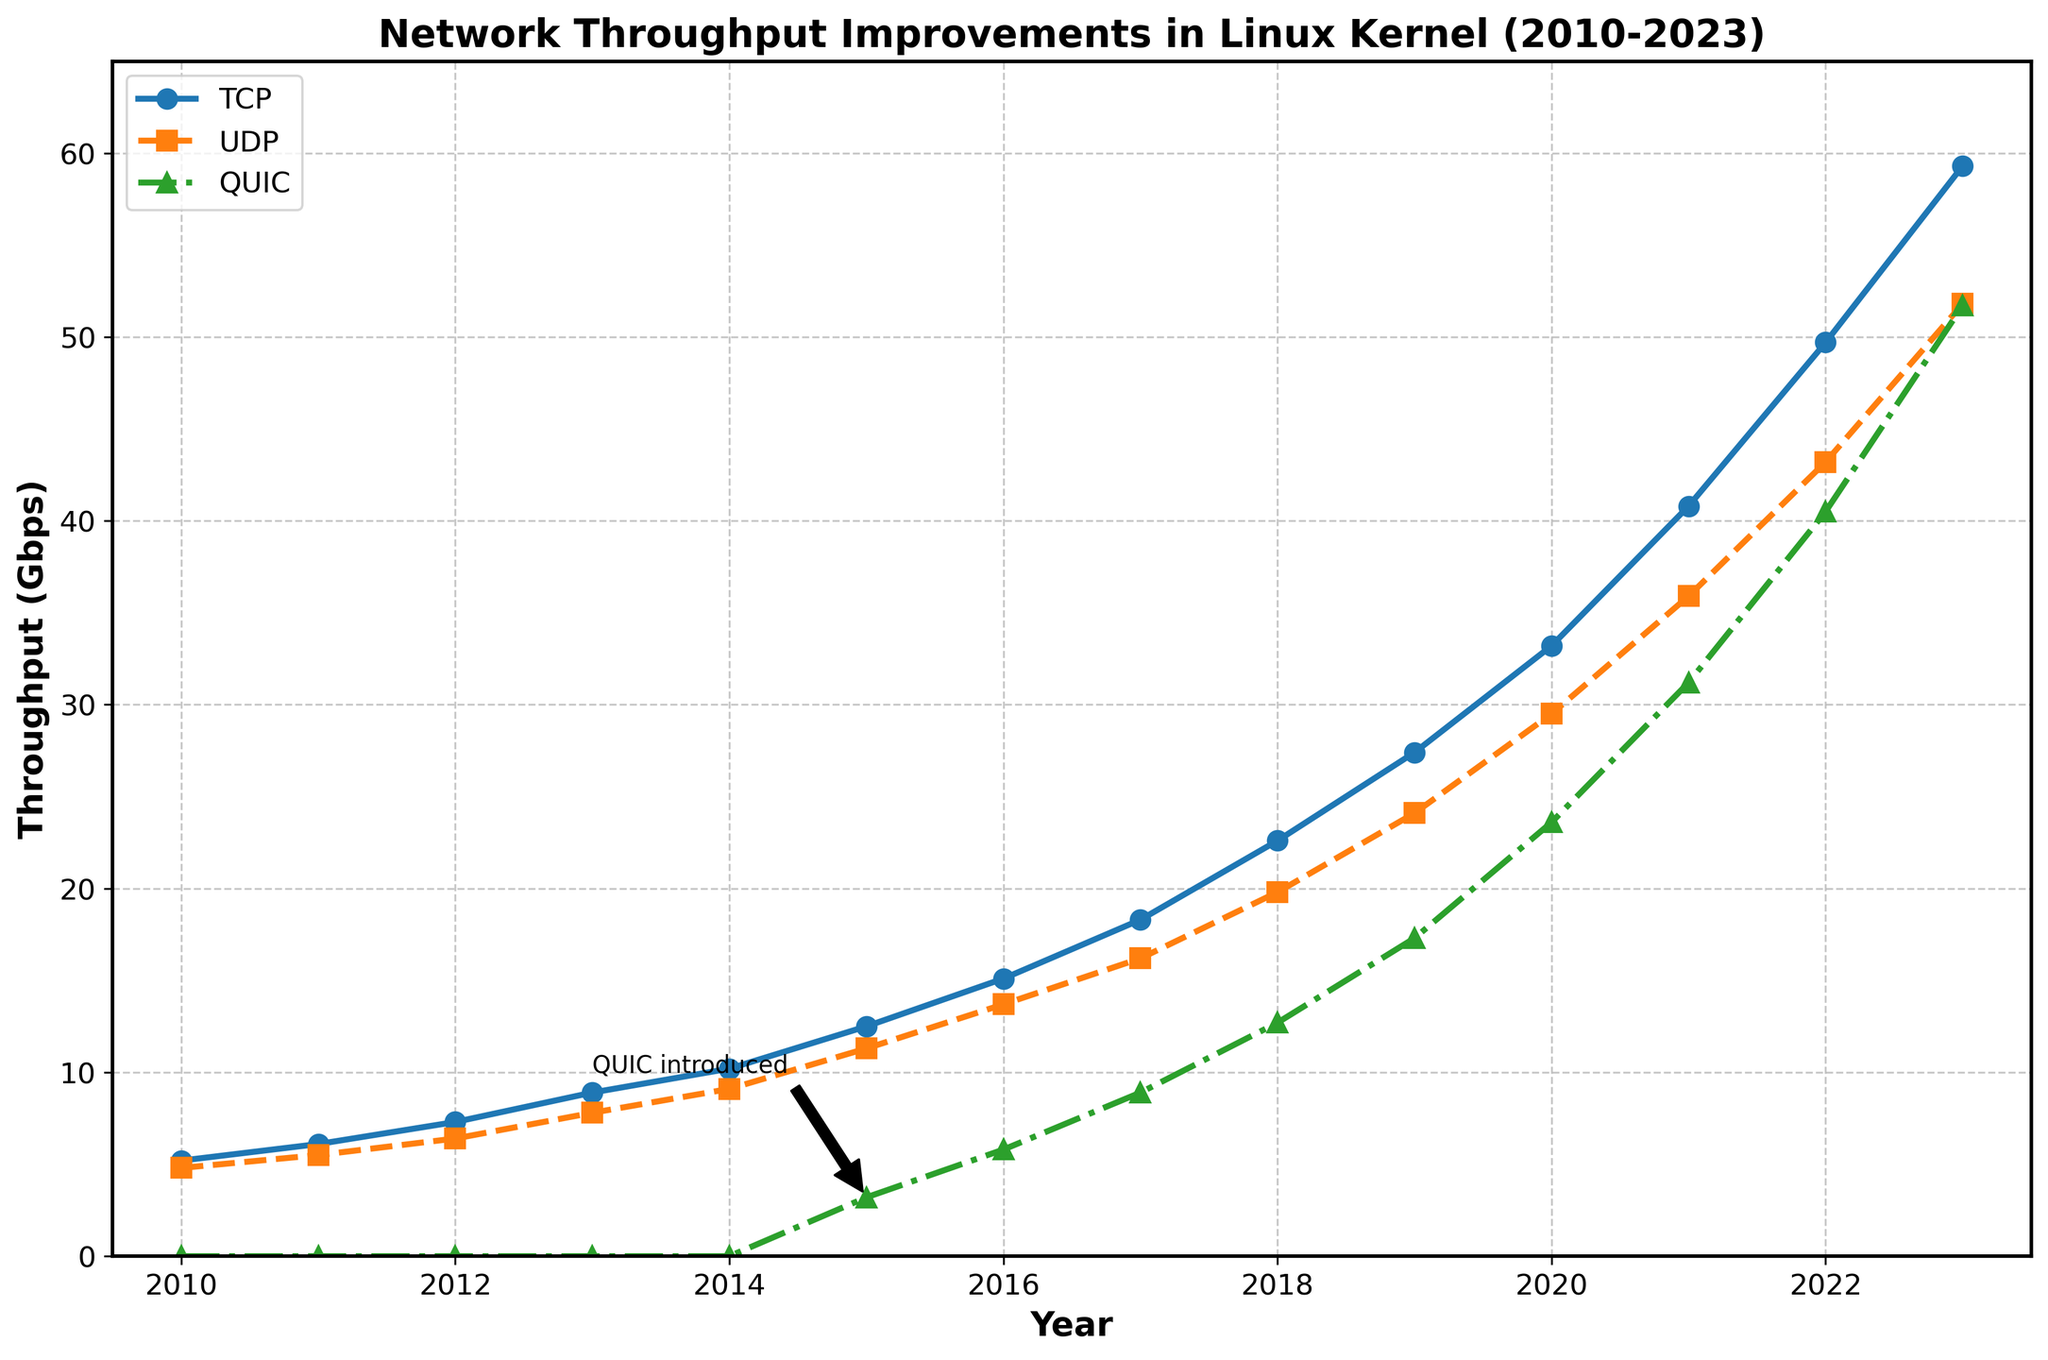What's the year with the highest UDP throughput? The UDP throughput values reach their highest in 2023 on the chart. Simply locate the endpoint of the UDP curve at the rightmost side (2023), which shows the maximum UDP throughput value.
Answer: 2023 Which protocol shows the least improvement in throughput over the entire period? Notice the shapes of the lines for TCP, UDP, and QUIC. QUIC starts in 2015. By observing the steepness of the lines from 2010 to 2023, TCP and UDP have shown significant increases, but QUIC has fewer years of data and thus a smaller absolute improvement over the same period.
Answer: QUIC Between which consecutive years is the throughput increase for TCP the highest? Observe the slope of the TCP line for each pair of consecutive years. The steepest segment indicating the highest year-to-year increase is between 2021 and 2022.
Answer: 2021-2022 What is the average throughput of QUIC in 2015 and 2020? Identify QUIC's values at 2015 (3.2 Gbps) and 2020 (23.6 Gbps). Add these two values and divide by 2 to get the average: (3.2 + 23.6) / 2.
Answer: 13.4 Gbps How much higher is the TCP throughput in 2023 compared to 2010? Look at the TCP values in 2010 (5.2 Gbps) and 2023 (59.3 Gbps). Then, calculate the difference: 59.3 - 5.2.
Answer: 54.1 Gbps Between which years did QUIC show the highest rate of growth? Focus on the steepest incline for the QUIC line, which appears between 2021 and 2022. Identify the substantial growth in one year, indicating the maximum rate of growth.
Answer: 2021-2022 What is the difference between UDP and TCP throughput in 2018? Check the values for 2018: UDP (19.8 Gbps) and TCP (22.6 Gbps). Subtract UDP value from TCP value: 22.6 - 19.8.
Answer: 2.8 Gbps Which protocol had consistent yearly improvements from 2010 to 2023? Scan each protocol’s line. TCP and UDP lines steadily rise from 2010 to 2023 without any dips, whereas QUIC starts only in 2015. Both TCP and UDP show consistent yearly improvements over the full period.
Answer: TCP and UDP Identify the year QUIC was introduced and describe its initial throughput. Locate the point where the QUIC line starts which is 2015. Its throughput at that point is 3.2 Gbps, as indicated by the annotation "QUIC introduced".
Answer: 2015, 3.2 Gbps How many Gbps did TCP throughput improve between 2019 and 2023? Find the TCP throughput values for 2019 (27.4 Gbps) and 2023 (59.3 Gbps). Subtract the 2019 value from the 2023 value: 59.3 - 27.4.
Answer: 31.9 Gbps 